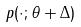<formula> <loc_0><loc_0><loc_500><loc_500>p ( \cdot ; \theta + \Delta )</formula> 